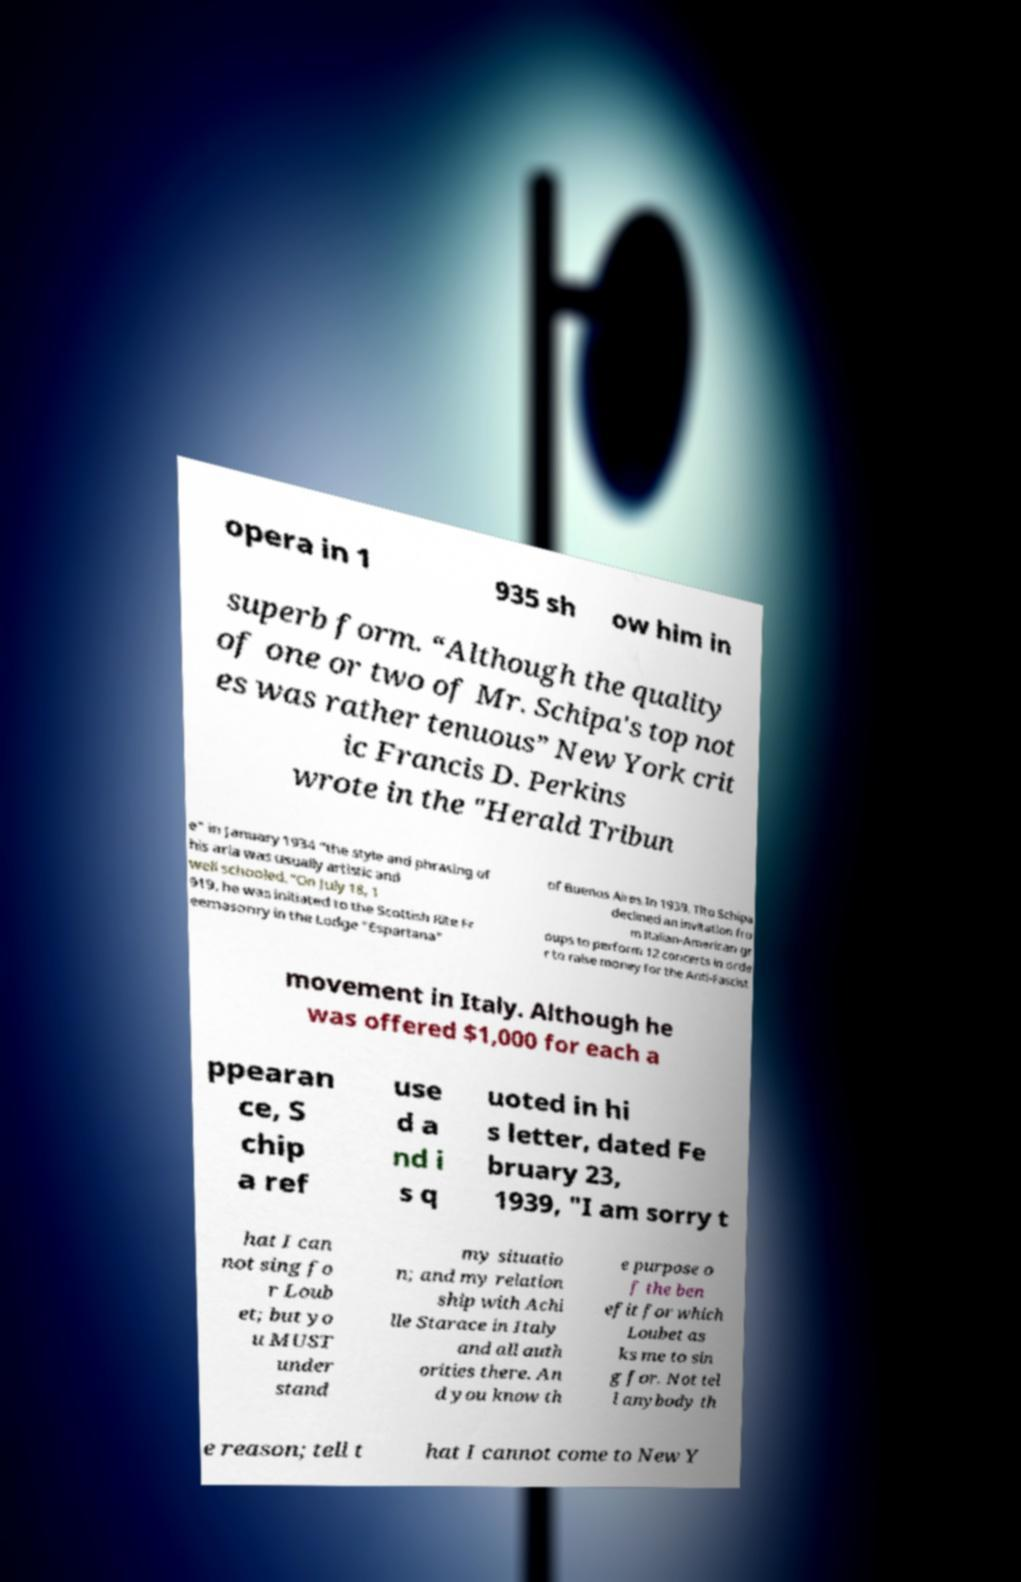Can you read and provide the text displayed in the image?This photo seems to have some interesting text. Can you extract and type it out for me? opera in 1 935 sh ow him in superb form. “Although the quality of one or two of Mr. Schipa's top not es was rather tenuous” New York crit ic Francis D. Perkins wrote in the "Herald Tribun e" in January 1934 “the style and phrasing of his aria was usually artistic and well schooled.”On July 18, 1 919, he was initiated to the Scottish Rite Fr eemasonry in the Lodge "Espartana" of Buenos Aires.In 1939, Tito Schipa declined an invitation fro m Italian-American gr oups to perform 12 concerts in orde r to raise money for the Anti-Fascist movement in Italy. Although he was offered $1,000 for each a ppearan ce, S chip a ref use d a nd i s q uoted in hi s letter, dated Fe bruary 23, 1939, "I am sorry t hat I can not sing fo r Loub et; but yo u MUST under stand my situatio n; and my relation ship with Achi lle Starace in Italy and all auth orities there. An d you know th e purpose o f the ben efit for which Loubet as ks me to sin g for. Not tel l anybody th e reason; tell t hat I cannot come to New Y 